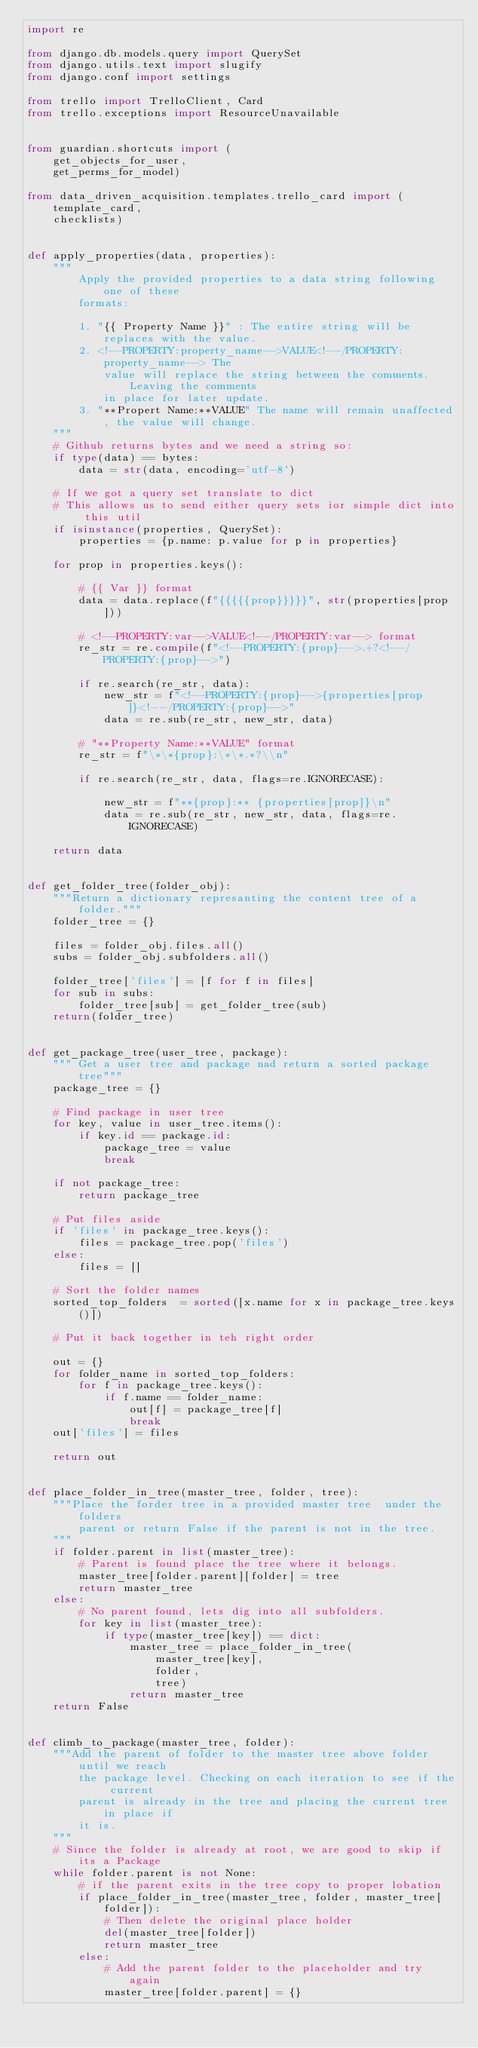<code> <loc_0><loc_0><loc_500><loc_500><_Python_>import re

from django.db.models.query import QuerySet
from django.utils.text import slugify
from django.conf import settings

from trello import TrelloClient, Card
from trello.exceptions import ResourceUnavailable


from guardian.shortcuts import (
    get_objects_for_user,
    get_perms_for_model)

from data_driven_acquisition.templates.trello_card import (
    template_card,
    checklists)


def apply_properties(data, properties):
    """
        Apply the provided properties to a data string following one of these
        formats:

        1. "{{ Property Name }}" : The entire string will be replaces with the value.
        2. <!--PROPERTY:property_name-->VALUE<!--/PROPERTY:property_name--> The
            value will replace the string between the comments. Leaving the comments
            in place for later update.
        3. "**Propert Name:**VALUE" The name will remain unaffected, the value will change.
    """
    # Github returns bytes and we need a string so:
    if type(data) == bytes:
        data = str(data, encoding='utf-8')

    # If we got a query set translate to dict
    # This allows us to send either query sets ior simple dict into this util
    if isinstance(properties, QuerySet):
        properties = {p.name: p.value for p in properties}

    for prop in properties.keys():

        # {{ Var }} format
        data = data.replace(f"{{{{{prop}}}}}", str(properties[prop]))

        # <!--PROPERTY:var-->VALUE<!--/PROPERTY:var--> format
        re_str = re.compile(f"<!--PROPERTY:{prop}-->.+?<!--/PROPERTY:{prop}-->")

        if re.search(re_str, data):
            new_str = f"<!--PROPERTY:{prop}-->{properties[prop]}<!--/PROPERTY:{prop}-->"
            data = re.sub(re_str, new_str, data)

        # "**Property Name:**VALUE" format
        re_str = f"\*\*{prop}:\*\*.*?\\n"

        if re.search(re_str, data, flags=re.IGNORECASE):

            new_str = f"**{prop}:** {properties[prop]}\n"
            data = re.sub(re_str, new_str, data, flags=re.IGNORECASE)

    return data


def get_folder_tree(folder_obj):
    """Return a dictionary represanting the content tree of a folder."""
    folder_tree = {}

    files = folder_obj.files.all()
    subs = folder_obj.subfolders.all()

    folder_tree['files'] = [f for f in files]
    for sub in subs:
        folder_tree[sub] = get_folder_tree(sub)
    return(folder_tree)


def get_package_tree(user_tree, package):
    """ Get a user tree and package nad return a sorted package tree"""
    package_tree = {}

    # Find package in user tree
    for key, value in user_tree.items():
        if key.id == package.id:
            package_tree = value
            break

    if not package_tree:
        return package_tree
    
    # Put files aside 
    if 'files' in package_tree.keys():
        files = package_tree.pop('files')
    else:
        files = []
    
    # Sort the folder names 
    sorted_top_folders  = sorted([x.name for x in package_tree.keys()])

    # Put it back together in teh right order

    out = {}
    for folder_name in sorted_top_folders:
        for f in package_tree.keys():
            if f.name == folder_name:
                out[f] = package_tree[f]
                break
    out['files'] = files

    return out


def place_folder_in_tree(master_tree, folder, tree):
    """Place the forder tree in a provided master tree  under the folders
        parent or return False if the parent is not in the tree.
    """
    if folder.parent in list(master_tree):
        # Parent is found place the tree where it belongs.
        master_tree[folder.parent][folder] = tree
        return master_tree
    else:
        # No parent found, lets dig into all subfolders.
        for key in list(master_tree):
            if type(master_tree[key]) == dict:
                master_tree = place_folder_in_tree(
                    master_tree[key],
                    folder,
                    tree)
                return master_tree
    return False


def climb_to_package(master_tree, folder):
    """Add the parent of folder to the master tree above folder until we reach
        the package level. Checking on each iteration to see if the current
        parent is already in the tree and placing the current tree in place if
        it is.
    """
    # Since the folder is already at root, we are good to skip if its a Package
    while folder.parent is not None:
        # if the parent exits in the tree copy to proper lobation
        if place_folder_in_tree(master_tree, folder, master_tree[folder]):
            # Then delete the original place holder
            del(master_tree[folder])
            return master_tree
        else:
            # Add the parent folder to the placeholder and try again
            master_tree[folder.parent] = {}</code> 